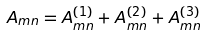Convert formula to latex. <formula><loc_0><loc_0><loc_500><loc_500>A _ { m n } = A _ { m n } ^ { ( 1 ) } + A _ { m n } ^ { ( 2 ) } + A _ { m n } ^ { ( 3 ) }</formula> 